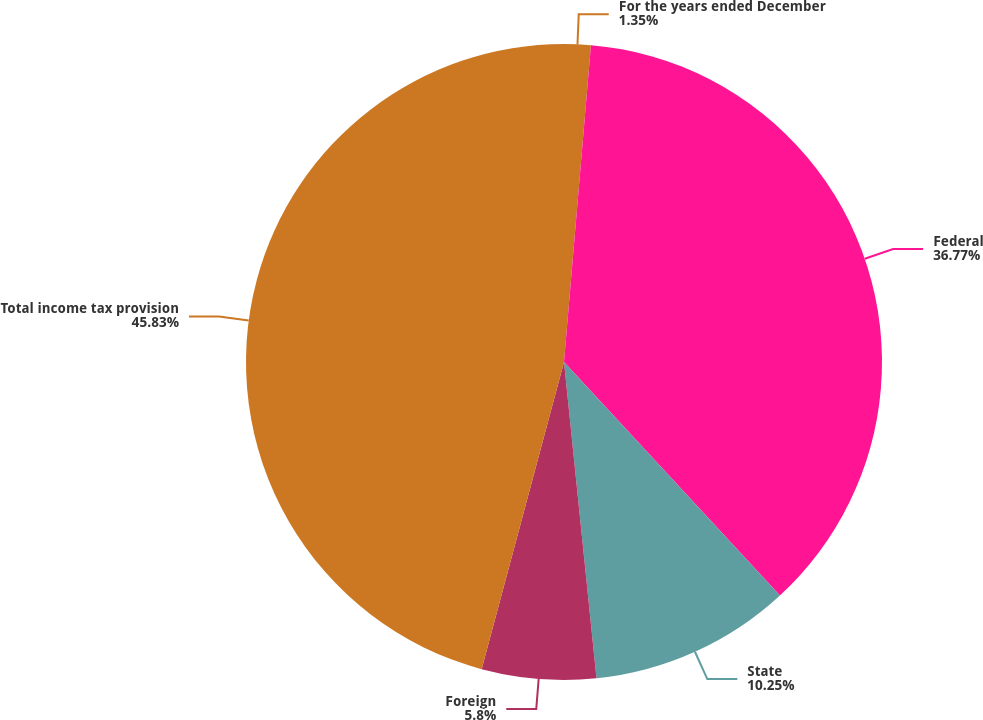Convert chart. <chart><loc_0><loc_0><loc_500><loc_500><pie_chart><fcel>For the years ended December<fcel>Federal<fcel>State<fcel>Foreign<fcel>Total income tax provision<nl><fcel>1.35%<fcel>36.77%<fcel>10.25%<fcel>5.8%<fcel>45.83%<nl></chart> 